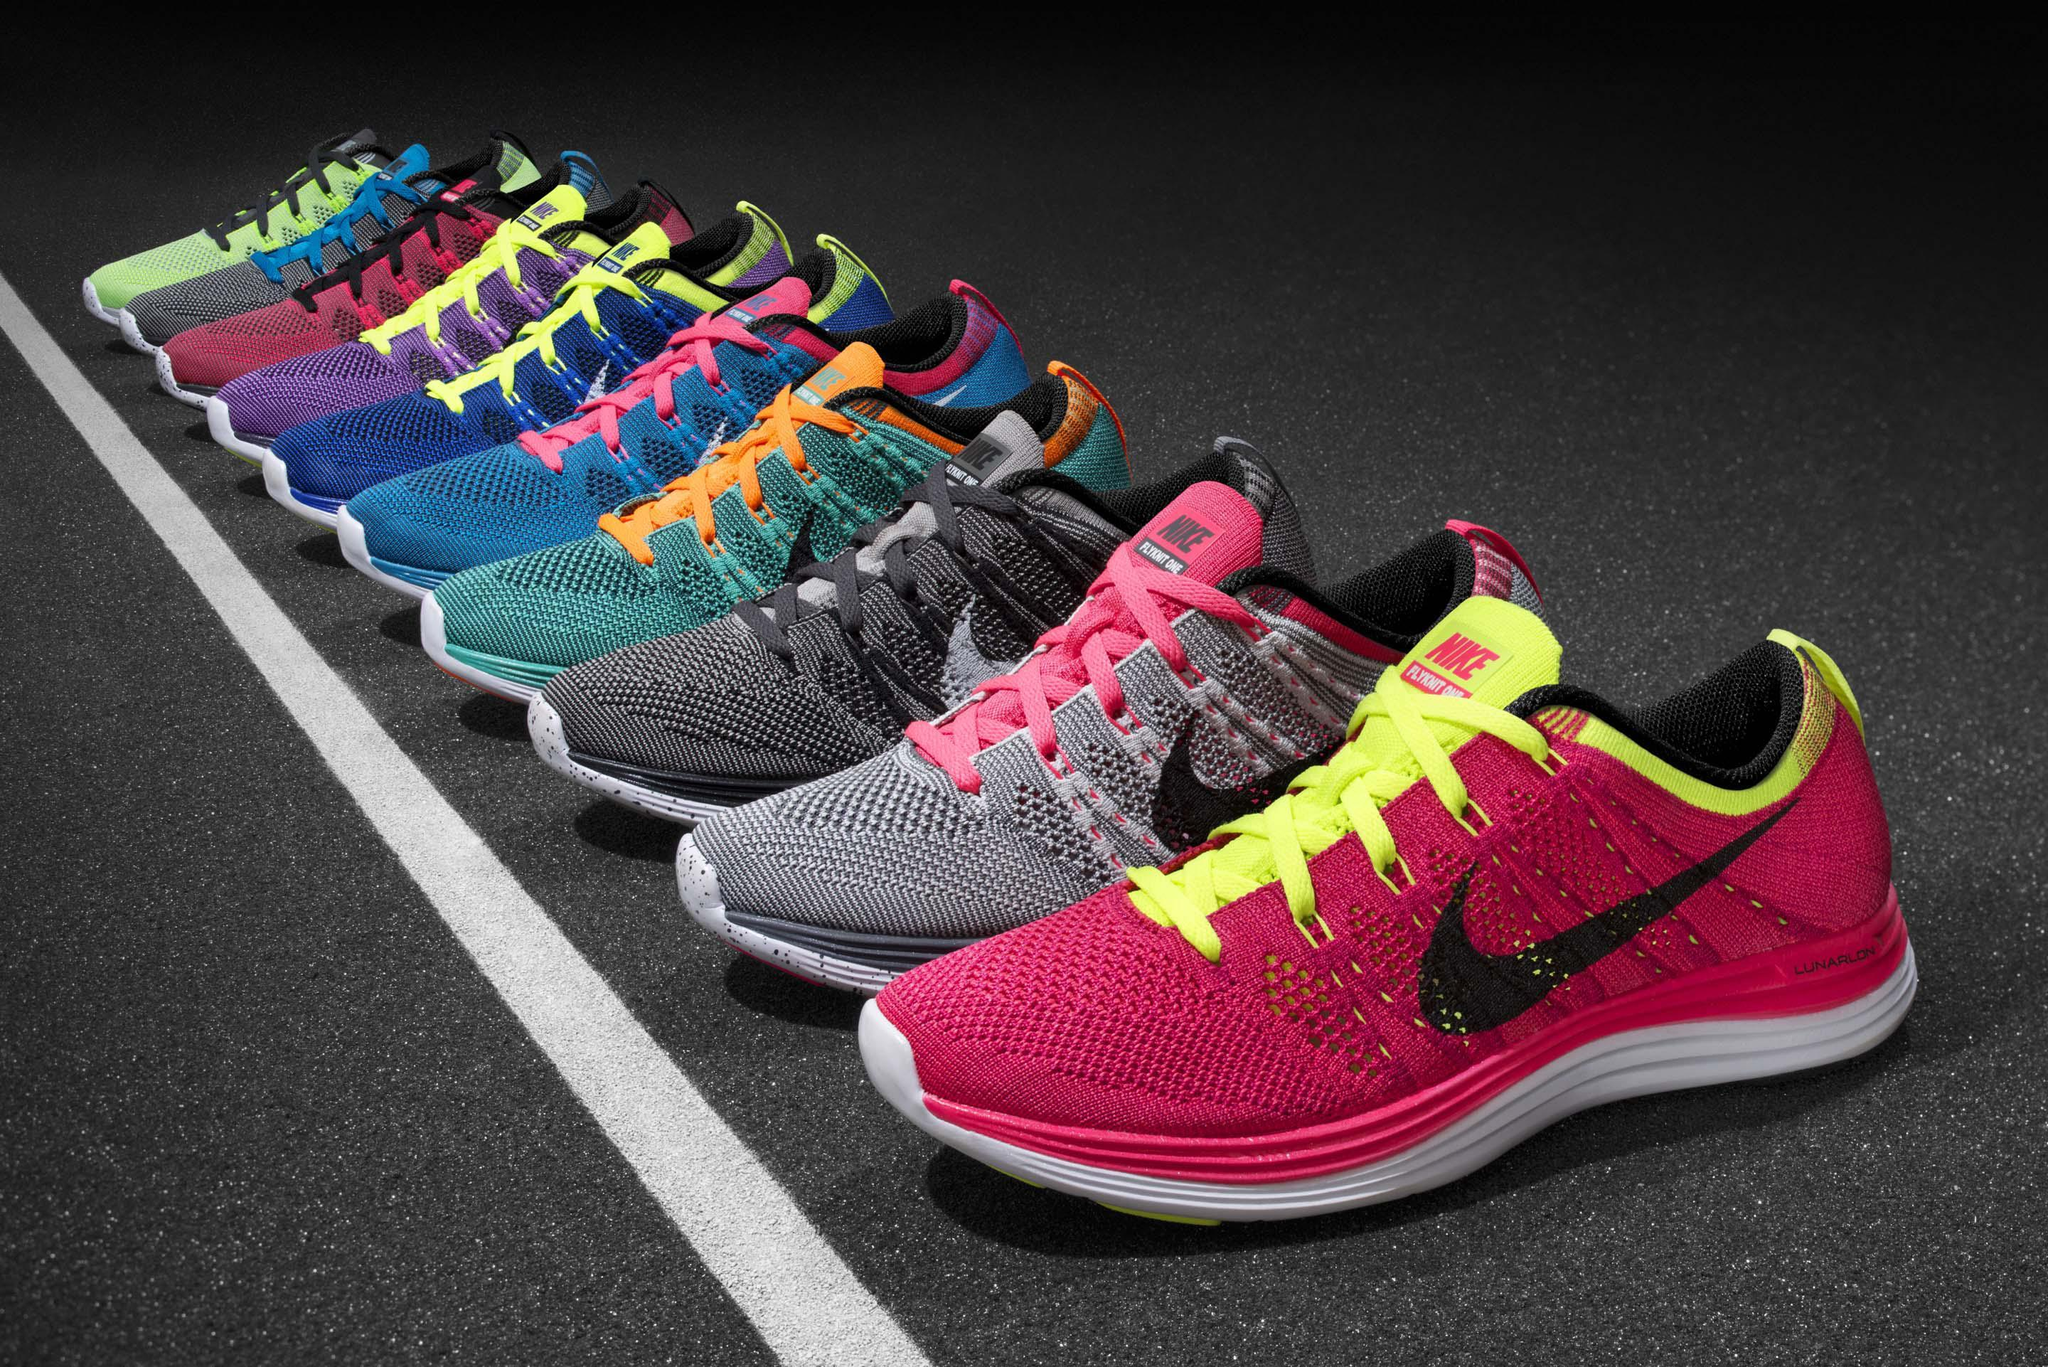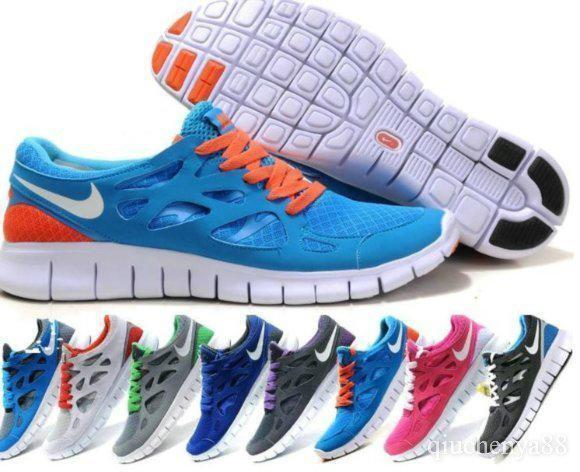The first image is the image on the left, the second image is the image on the right. For the images shown, is this caption "The shoes are flat on the ground and sitting right next to each other in the right image." true? Answer yes or no. No. The first image is the image on the left, the second image is the image on the right. Evaluate the accuracy of this statement regarding the images: "One image shows a matching pair of shoe facing the right.". Is it true? Answer yes or no. No. 